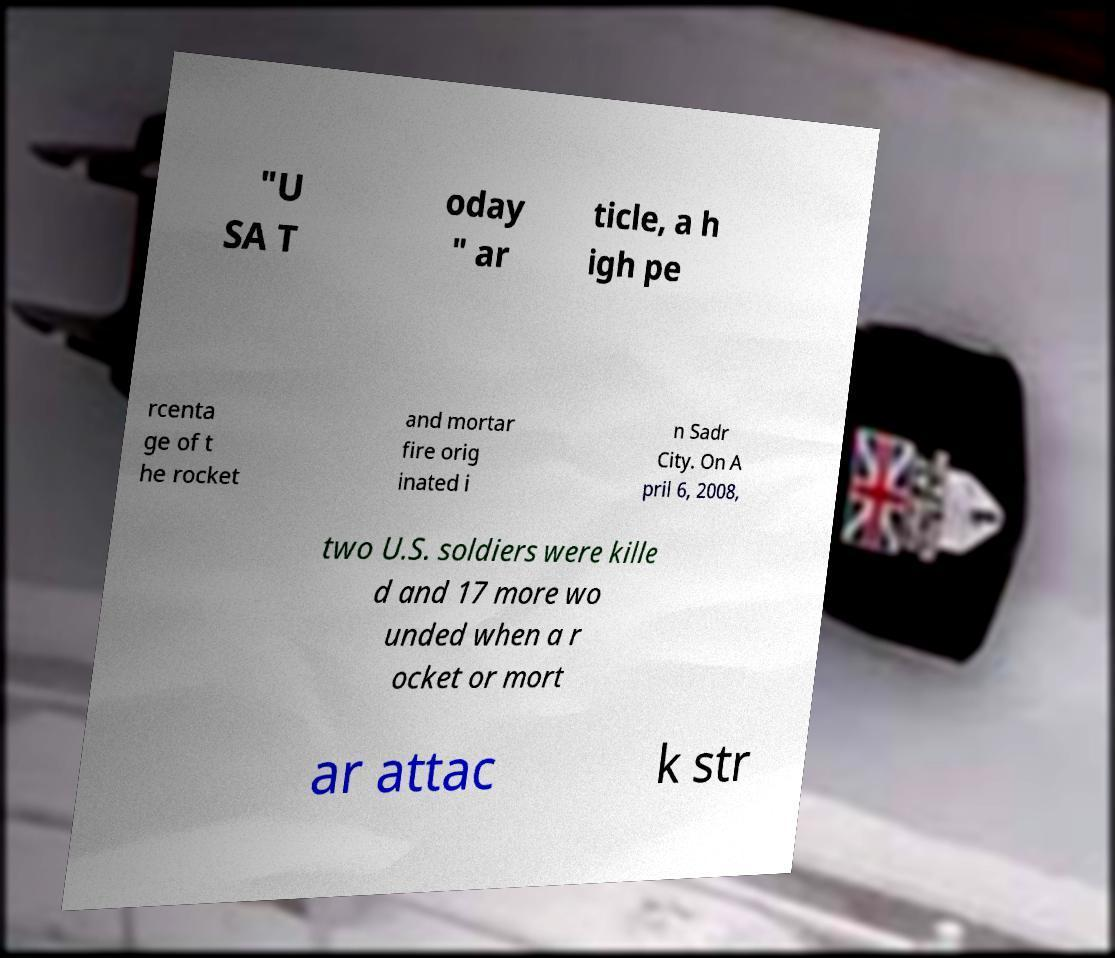I need the written content from this picture converted into text. Can you do that? "U SA T oday " ar ticle, a h igh pe rcenta ge of t he rocket and mortar fire orig inated i n Sadr City. On A pril 6, 2008, two U.S. soldiers were kille d and 17 more wo unded when a r ocket or mort ar attac k str 